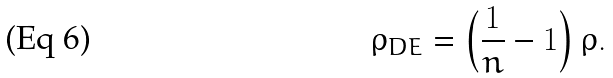<formula> <loc_0><loc_0><loc_500><loc_500>\rho _ { D E } = \left ( \frac { 1 } { n } - 1 \right ) \rho .</formula> 